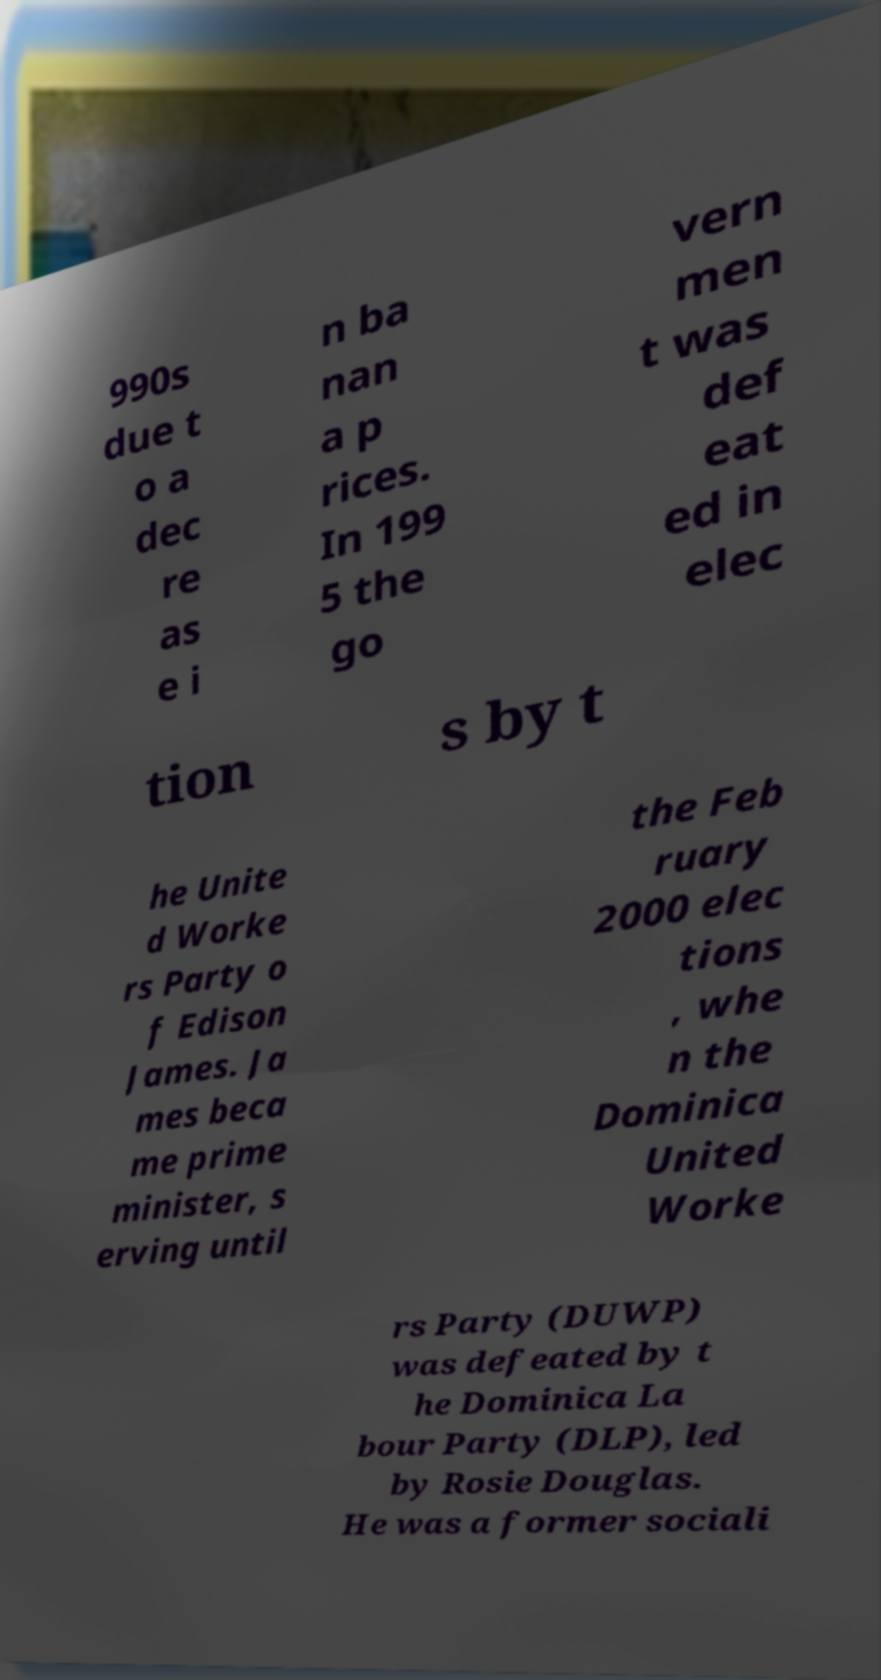Can you read and provide the text displayed in the image?This photo seems to have some interesting text. Can you extract and type it out for me? 990s due t o a dec re as e i n ba nan a p rices. In 199 5 the go vern men t was def eat ed in elec tion s by t he Unite d Worke rs Party o f Edison James. Ja mes beca me prime minister, s erving until the Feb ruary 2000 elec tions , whe n the Dominica United Worke rs Party (DUWP) was defeated by t he Dominica La bour Party (DLP), led by Rosie Douglas. He was a former sociali 